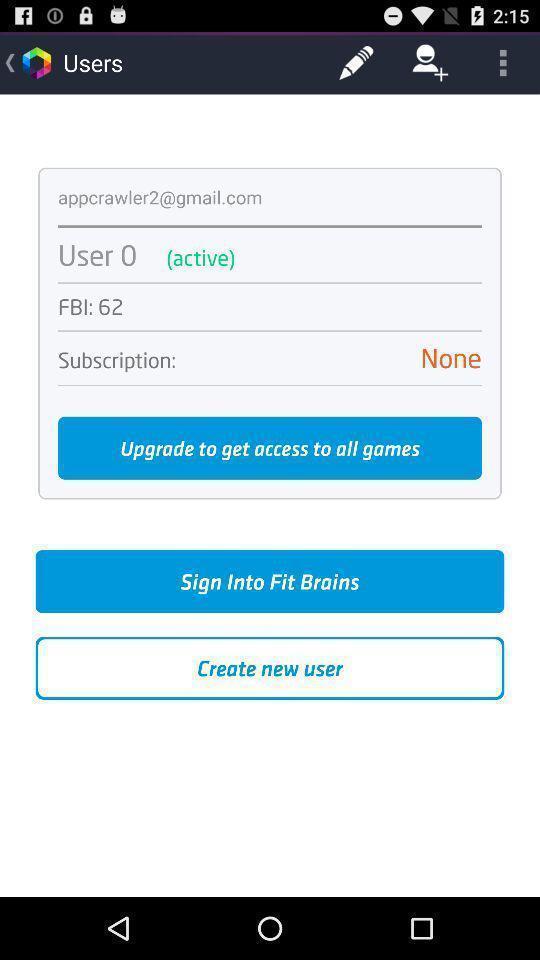Give me a narrative description of this picture. Starting page of the application with several options in application. 